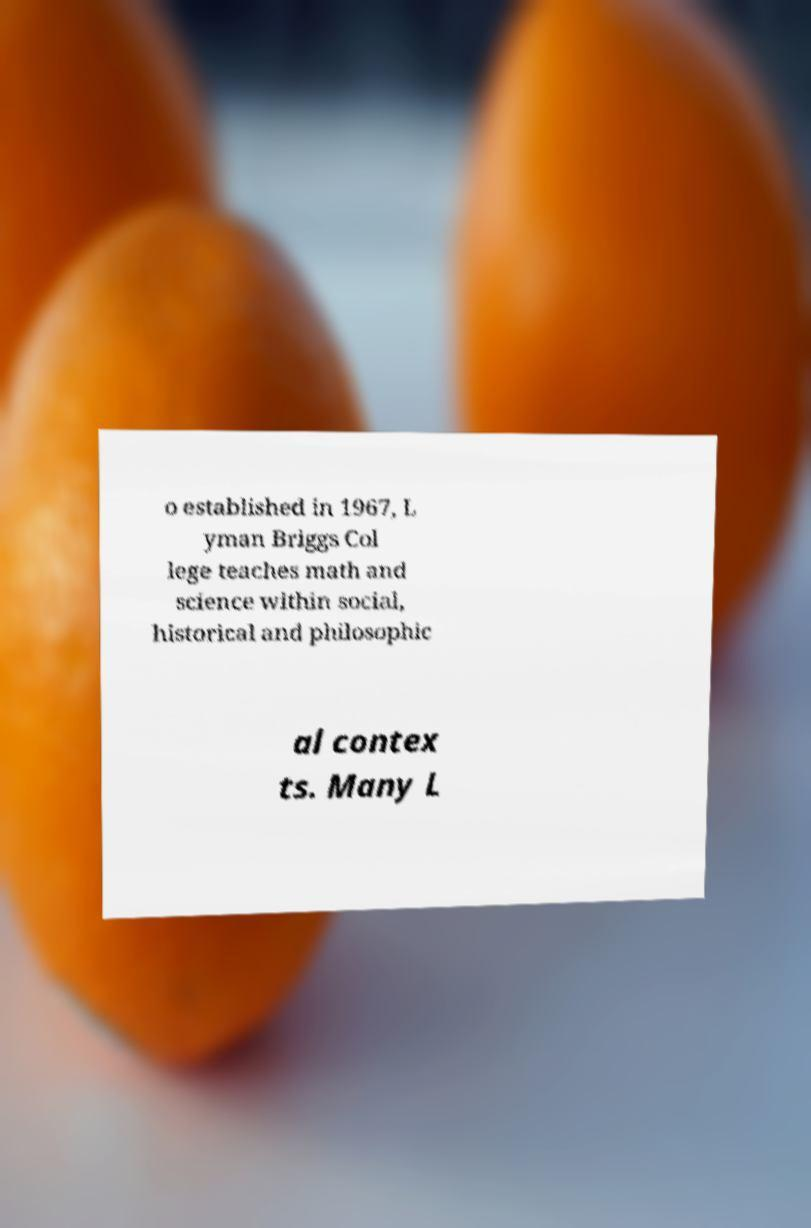Please read and relay the text visible in this image. What does it say? o established in 1967, L yman Briggs Col lege teaches math and science within social, historical and philosophic al contex ts. Many L 